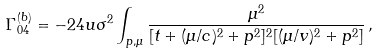Convert formula to latex. <formula><loc_0><loc_0><loc_500><loc_500>\Gamma _ { 0 4 } ^ { ( b ) } = - 2 4 u \sigma ^ { 2 } \int _ { { p } , \mu } \frac { \mu ^ { 2 } } { [ t + ( \mu / c ) ^ { 2 } + p ^ { 2 } ] ^ { 2 } [ ( \mu / v ) ^ { 2 } + p ^ { 2 } ] } \, ,</formula> 